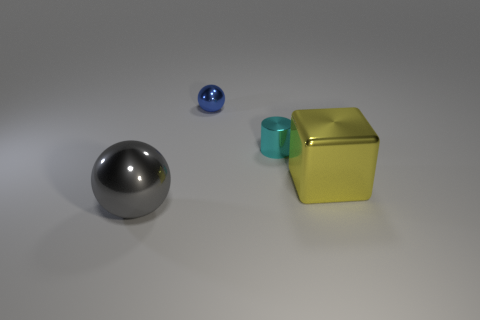What number of other things are the same size as the yellow metallic thing?
Your response must be concise. 1. What number of cyan cylinders have the same material as the big cube?
Ensure brevity in your answer.  1. Are there the same number of gray shiny spheres right of the large gray thing and small cyan things?
Your response must be concise. No. What size is the metal ball that is to the left of the tiny metal ball?
Your answer should be compact. Large. What number of tiny objects are either blue balls or yellow cubes?
Make the answer very short. 1. What is the color of the other tiny shiny object that is the same shape as the gray thing?
Your response must be concise. Blue. Is the blue metal object the same size as the shiny cylinder?
Provide a short and direct response. Yes. What number of things are either large metallic balls or shiny balls that are in front of the cyan metal cylinder?
Provide a succinct answer. 1. What is the color of the big object that is behind the large thing to the left of the small blue shiny object?
Your answer should be compact. Yellow. What is the material of the large object that is to the right of the big ball?
Your answer should be very brief. Metal. 